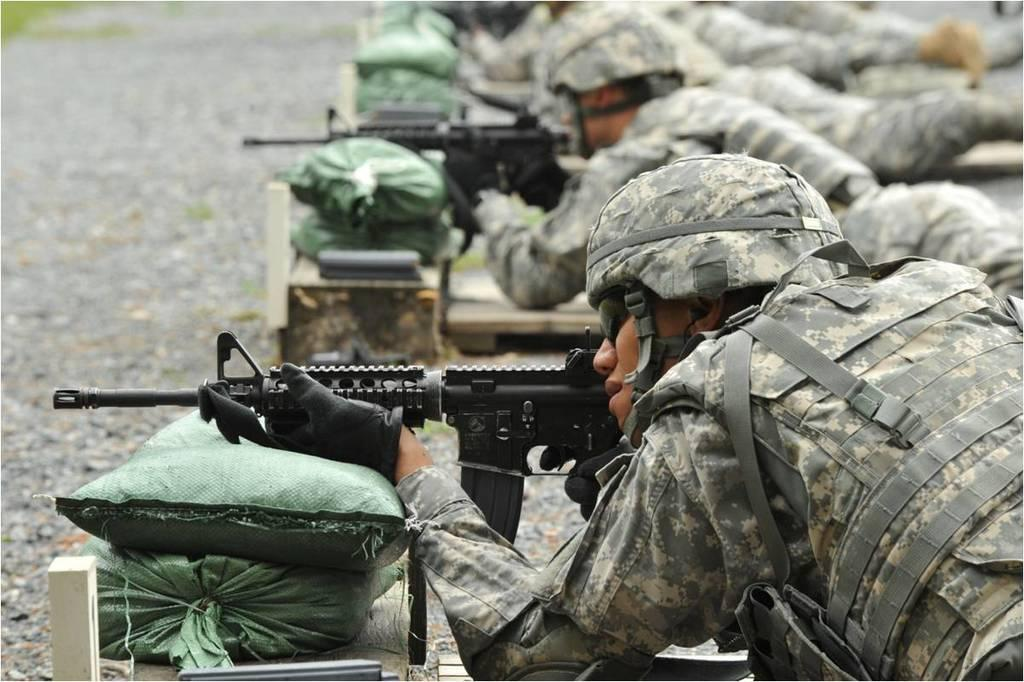What type of protective gear are the people wearing in the image? The people are wearing helmets, gloves, and goggles in the image. What are the people holding in their hands? The people are holding guns in the image. What are the sacks in front of the people doing? The sacks are lying on the ground in front of the people. Can you describe the background of the image? The background of the image is blurred. How many faces can be seen on the people's legs in the image? There are no faces visible on the people's legs in the image. 